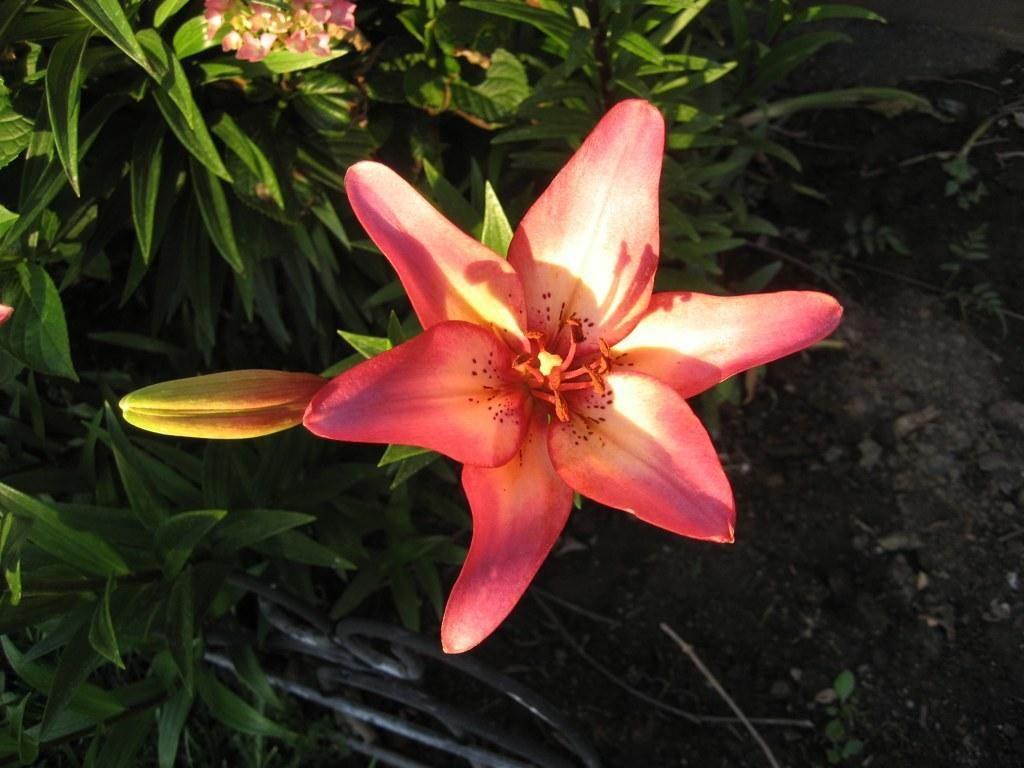What type of plant can be seen in the image? There is a flower in the image. What color are the leaves associated with the flower? There are green leaves in the image. What type of shoe can be seen in the image? There is no shoe present in the image; it only features a flower and green leaves. What activity is taking place in the image? There is no specific activity depicted in the image; it simply shows a flower and green leaves. 